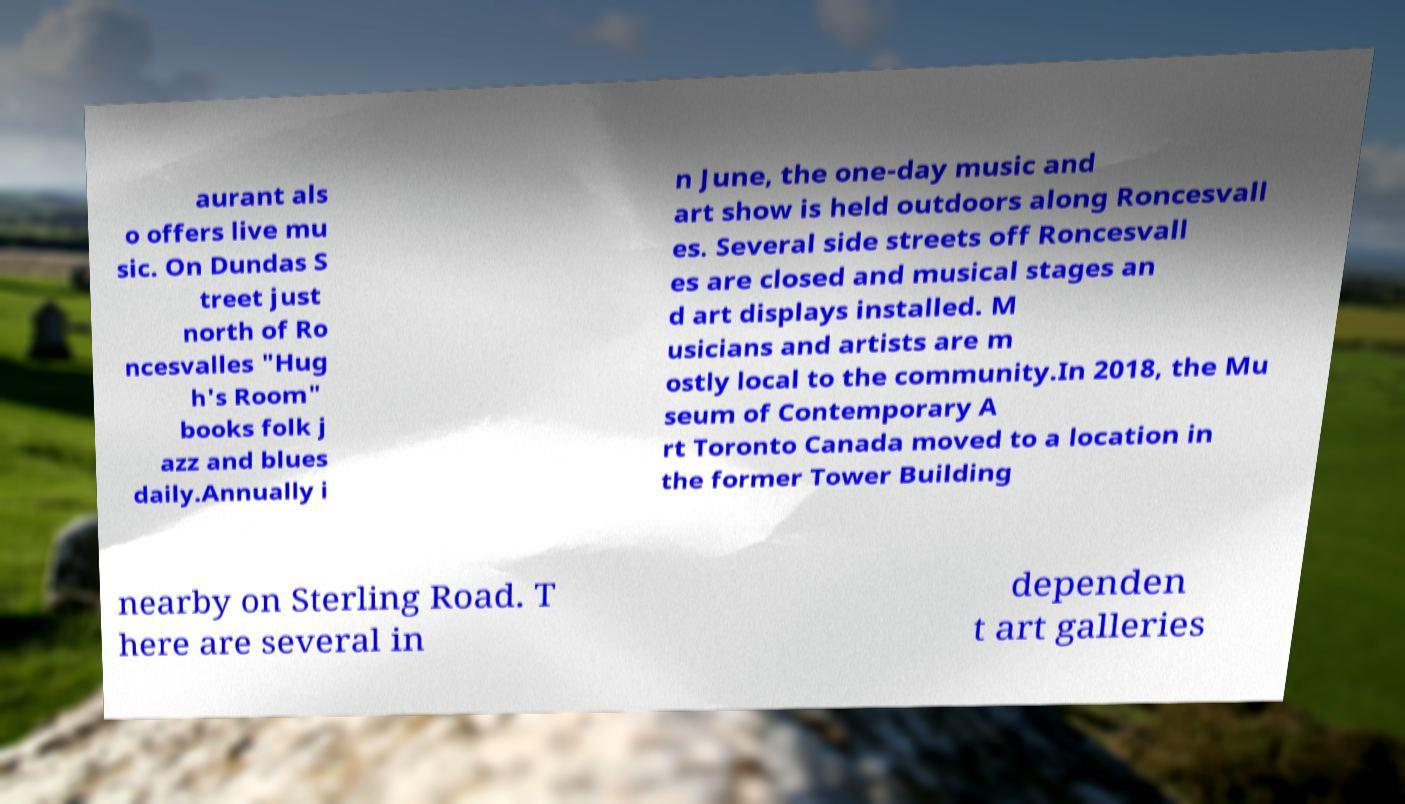Please read and relay the text visible in this image. What does it say? aurant als o offers live mu sic. On Dundas S treet just north of Ro ncesvalles "Hug h's Room" books folk j azz and blues daily.Annually i n June, the one-day music and art show is held outdoors along Roncesvall es. Several side streets off Roncesvall es are closed and musical stages an d art displays installed. M usicians and artists are m ostly local to the community.In 2018, the Mu seum of Contemporary A rt Toronto Canada moved to a location in the former Tower Building nearby on Sterling Road. T here are several in dependen t art galleries 